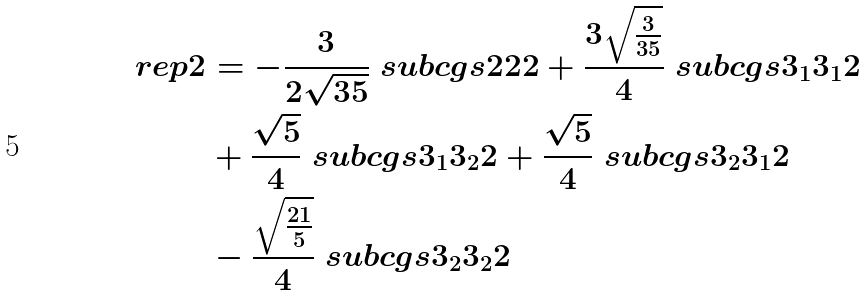Convert formula to latex. <formula><loc_0><loc_0><loc_500><loc_500>\ r e p { 2 } & = - \frac { 3 } { 2 \sqrt { 3 5 } } \ s u b c g s { 2 } { 2 } { 2 } + \frac { 3 \sqrt { \frac { 3 } { 3 5 } } } { 4 } \ s u b c g s { 3 _ { 1 } } { 3 _ { 1 } } { 2 } \\ & + \frac { \sqrt { 5 } } { 4 } \ s u b c g s { 3 _ { 1 } } { 3 _ { 2 } } { 2 } + \frac { \sqrt { 5 } } { 4 } \ s u b c g s { 3 _ { 2 } } { 3 _ { 1 } } { 2 } \\ & - \frac { \sqrt { \frac { 2 1 } { 5 } } } { 4 } \ s u b c g s { 3 _ { 2 } } { 3 _ { 2 } } { 2 }</formula> 